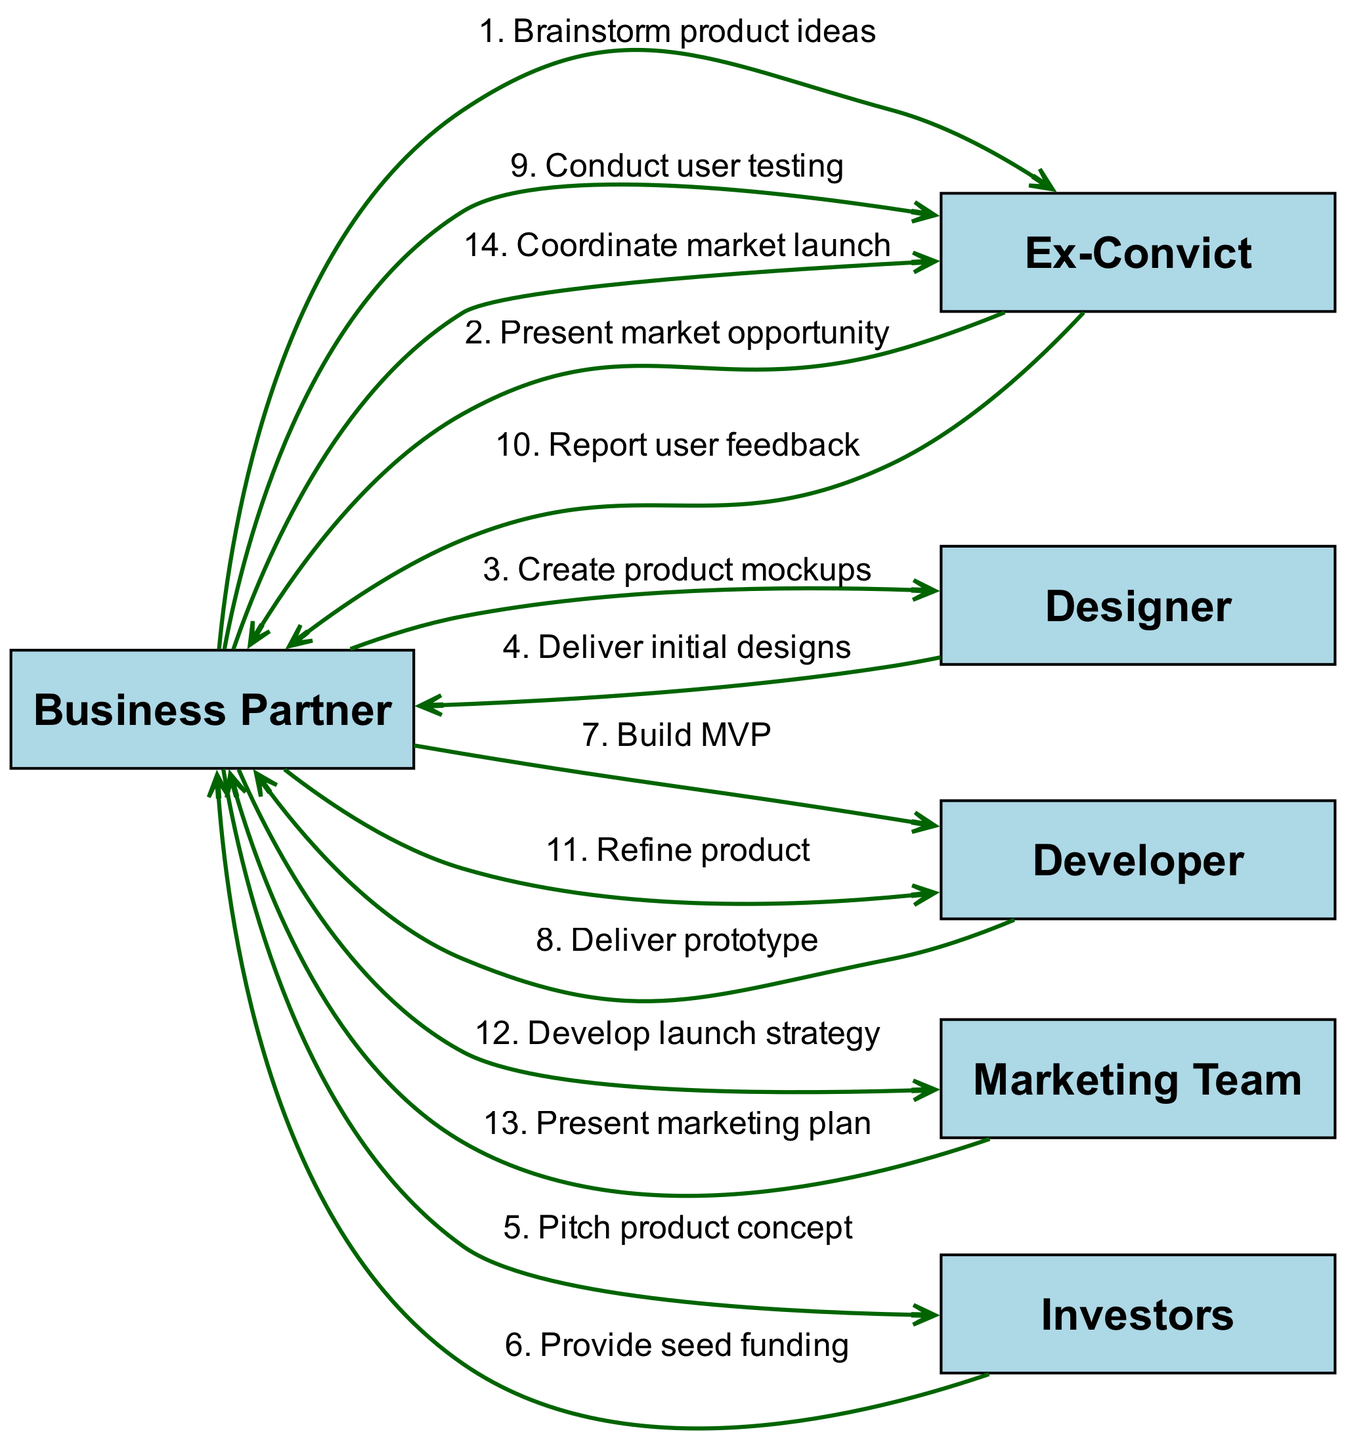What is the first message in the sequence? The first message in the sequence is from the "Business Partner" to the "Ex-Convict" stating "Brainstorm product ideas" which is the initial step in the product lifecycle.
Answer: Brainstorm product ideas How many total actors are in the diagram? The diagram includes six distinct actors: Business Partner, Ex-Convict, Designer, Developer, Marketing Team, and Investors. Counting these gives a total of six actors.
Answer: 6 Which actor receives the seed funding? The "Business Partner" is the actor who receives seed funding from the "Investors" after pitching the product concept.
Answer: Business Partner What is the last action mentioned in the sequence? The last action in the sequence is where the "Business Partner" coordinates the market launch with the "Ex-Convict," marking the final step before going to market.
Answer: Coordinate market launch How many steps involve the Developer? The Developer is involved in three steps: building the MVP, delivering the prototype, and refining the product. Counting these steps gives a total of three interactions.
Answer: 3 What feedback does the Ex-Convict provide? The Ex-Convict provides user feedback, which occurs after conducting user testing, indicating their role in assessing the user experience.
Answer: Report user feedback Which actor is involved in creating the product mockups? The "Designer" is responsible for creating product mockups upon request from the "Business Partner," as specified in the sequence.
Answer: Designer What is the relationship between the Business Partner and Marketing Team? The relationship is that the "Business Partner" instructs the "Marketing Team" to develop a launch strategy, indicating a directive relationship in the product's lifecycle.
Answer: Develop launch strategy What step follows the "Deliver prototype" action? The step that follows "Deliver prototype" is "Conduct user testing," indicating a continuation of the product development process based on the prototype feedback.
Answer: Conduct user testing 